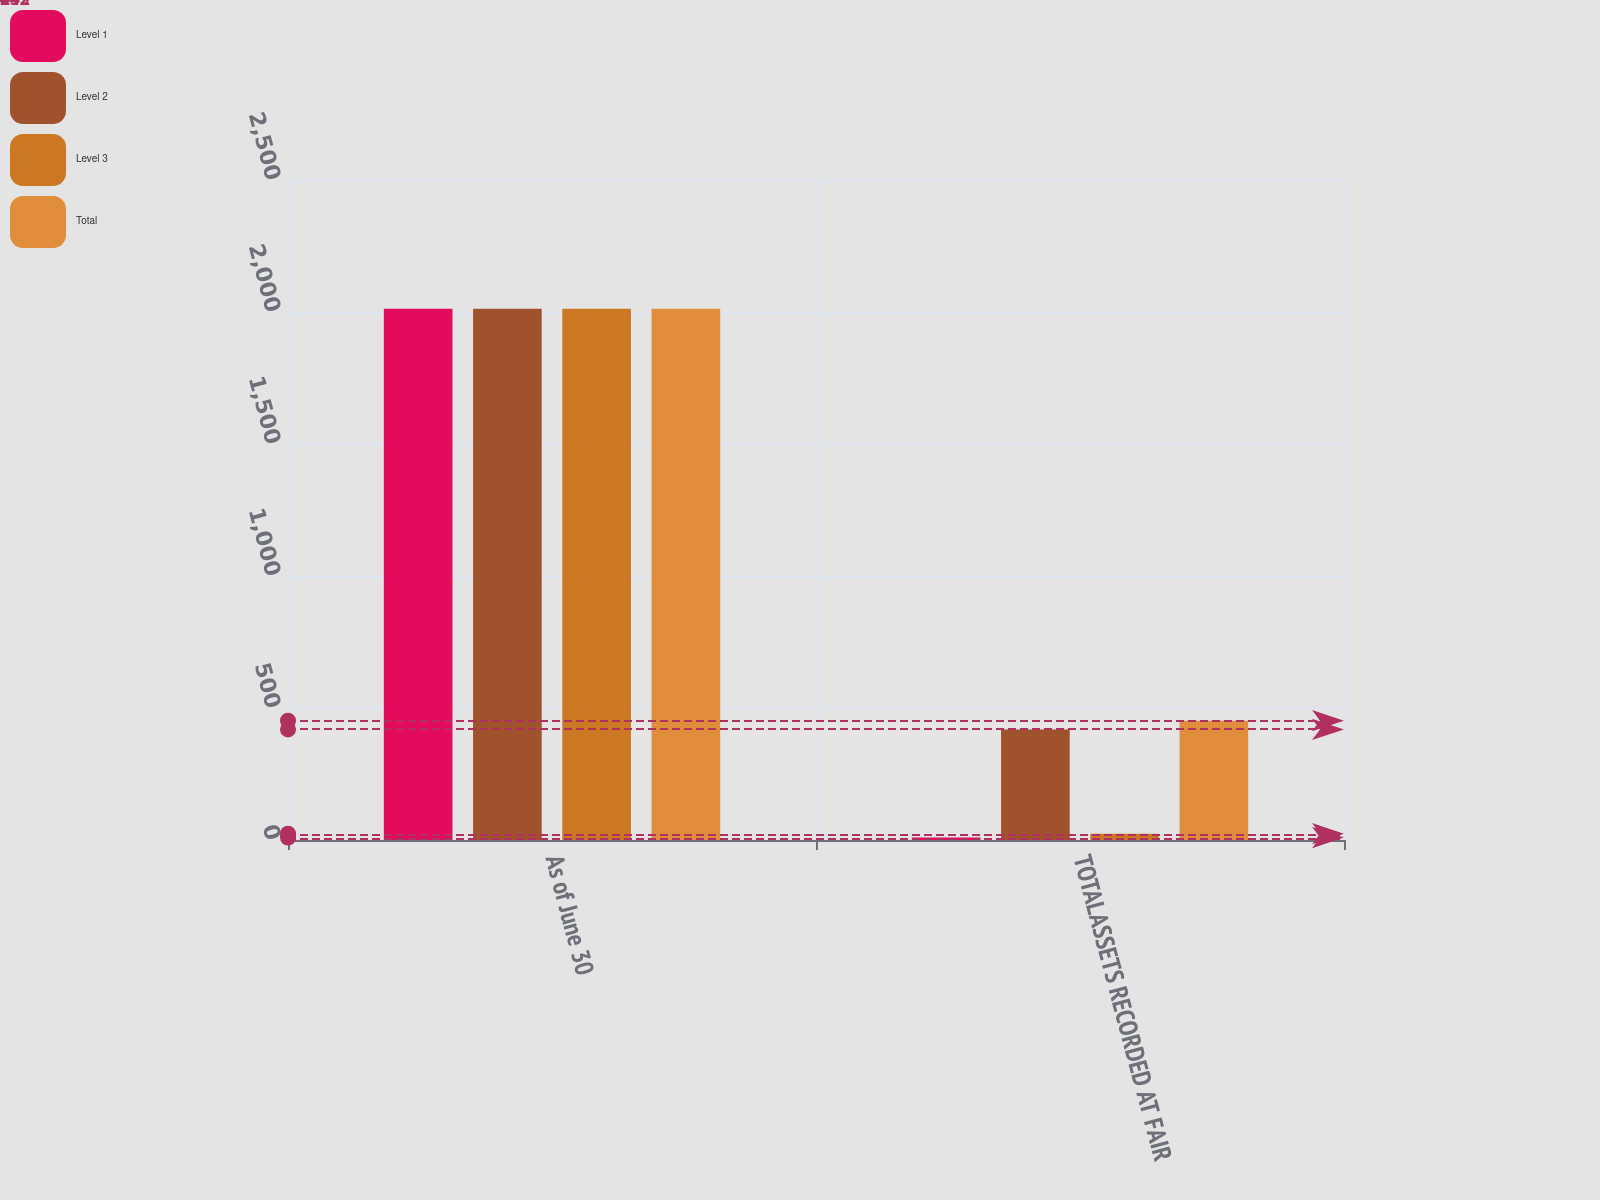Convert chart to OTSL. <chart><loc_0><loc_0><loc_500><loc_500><stacked_bar_chart><ecel><fcel>As of June 30<fcel>TOTALASSETS RECORDED AT FAIR<nl><fcel>Level 1<fcel>2012<fcel>9<nl><fcel>Level 2<fcel>2012<fcel>419<nl><fcel>Level 3<fcel>2012<fcel>24<nl><fcel>Total<fcel>2012<fcel>452<nl></chart> 